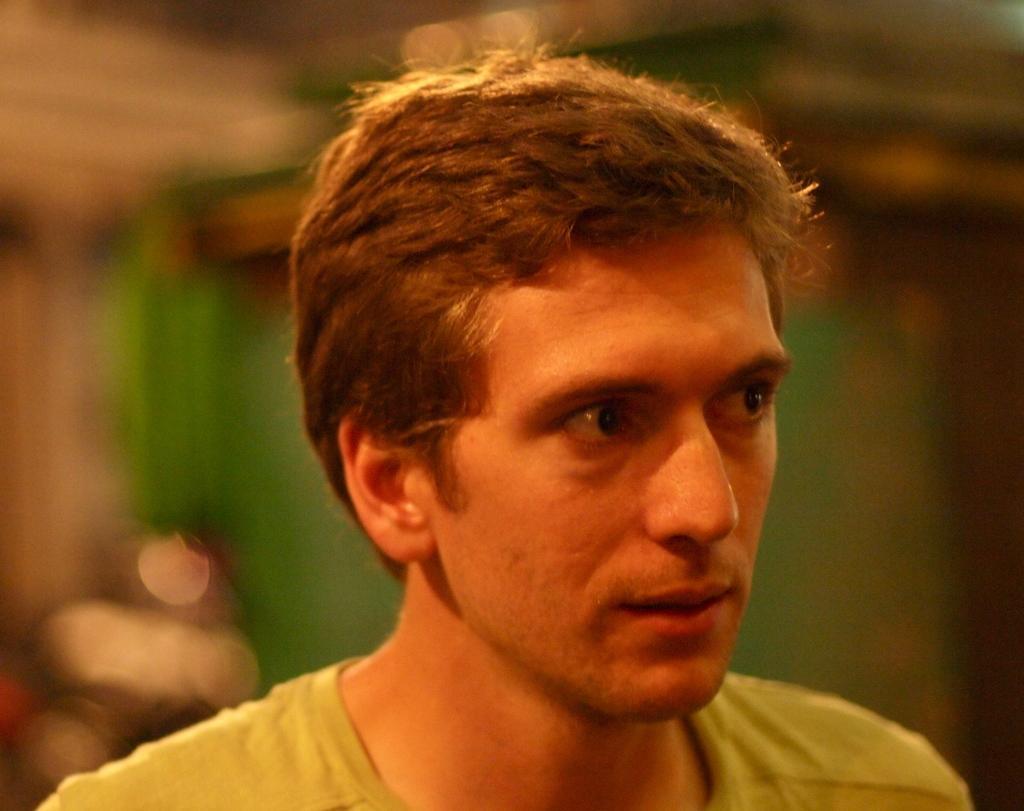Could you give a brief overview of what you see in this image? In the picture I can see a face of a person and there are some other objects in the background. 